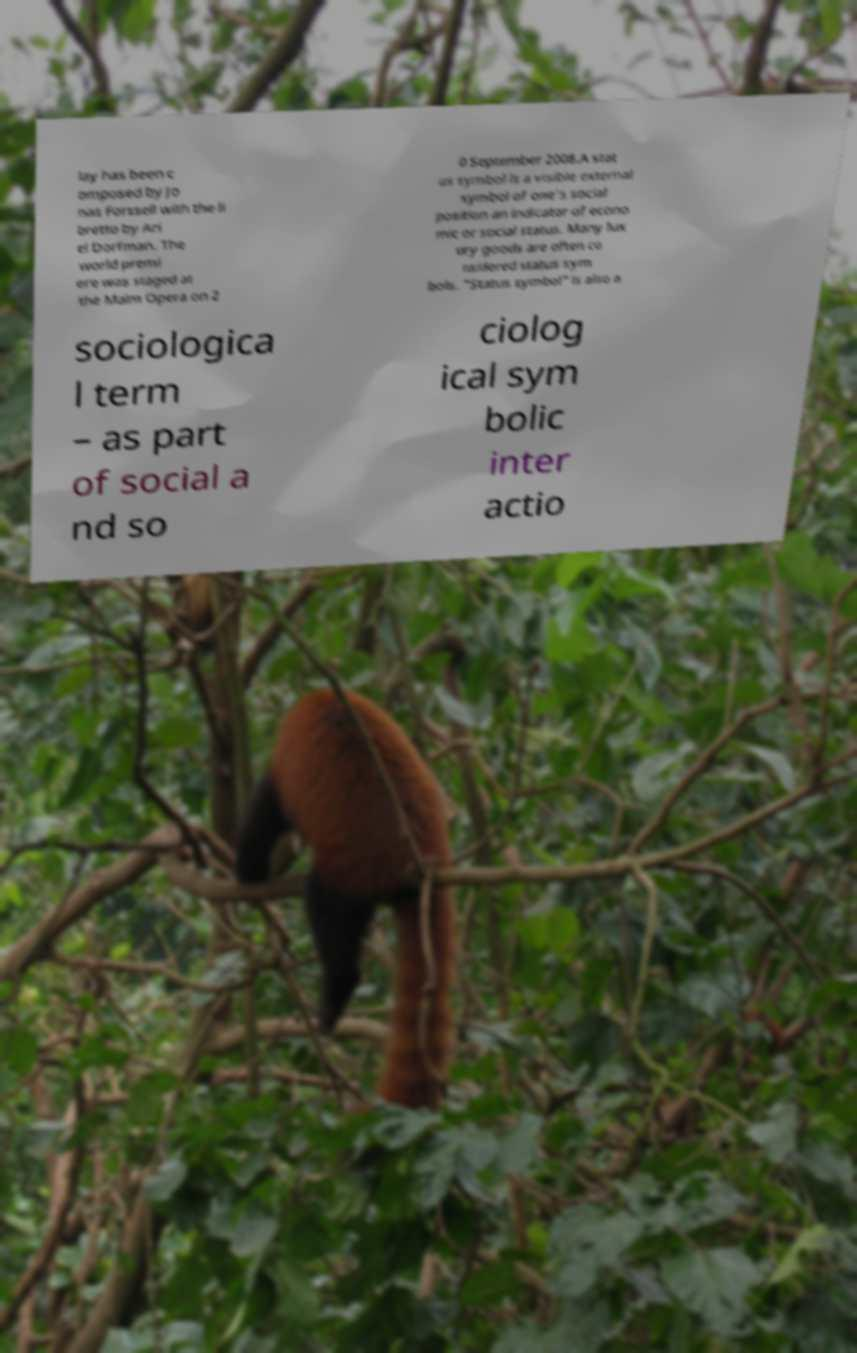Can you read and provide the text displayed in the image?This photo seems to have some interesting text. Can you extract and type it out for me? lay has been c omposed by Jo nas Forssell with the li bretto by Ari el Dorfman. The world premi ere was staged at the Malm Opera on 2 0 September 2008.A stat us symbol is a visible external symbol of one's social position an indicator of econo mic or social status. Many lux ury goods are often co nsidered status sym bols. "Status symbol" is also a sociologica l term – as part of social a nd so ciolog ical sym bolic inter actio 